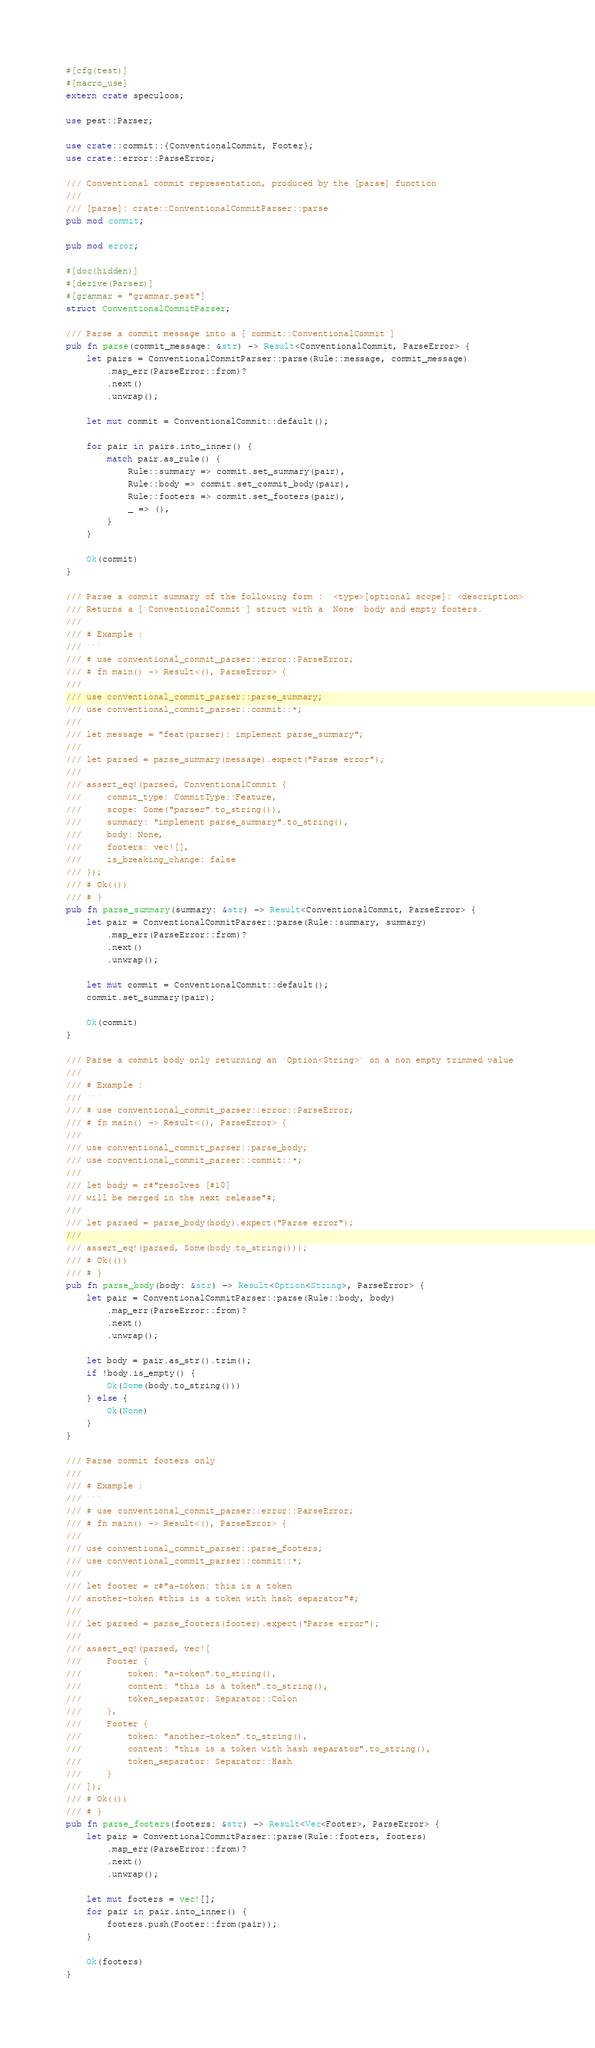Convert code to text. <code><loc_0><loc_0><loc_500><loc_500><_Rust_>#[cfg(test)]
#[macro_use]
extern crate speculoos;

use pest::Parser;

use crate::commit::{ConventionalCommit, Footer};
use crate::error::ParseError;

/// Conventional commit representation, produced by the [parse] function
///
/// [parse]: crate::ConventionalCommitParser::parse
pub mod commit;

pub mod error;

#[doc(hidden)]
#[derive(Parser)]
#[grammar = "grammar.pest"]
struct ConventionalCommitParser;

/// Parse a commit message into a [`commit::ConventionalCommit`]
pub fn parse(commit_message: &str) -> Result<ConventionalCommit, ParseError> {
    let pairs = ConventionalCommitParser::parse(Rule::message, commit_message)
        .map_err(ParseError::from)?
        .next()
        .unwrap();

    let mut commit = ConventionalCommit::default();

    for pair in pairs.into_inner() {
        match pair.as_rule() {
            Rule::summary => commit.set_summary(pair),
            Rule::body => commit.set_commit_body(pair),
            Rule::footers => commit.set_footers(pair),
            _ => (),
        }
    }

    Ok(commit)
}

/// Parse a commit summary of the following form : `<type>[optional scope]: <description>`
/// Returns a [`ConventionalCommit`] struct with a `None` body and empty footers.
///
/// # Example :
/// ```
/// # use conventional_commit_parser::error::ParseError;
/// # fn main() -> Result<(), ParseError> {
///
/// use conventional_commit_parser::parse_summary;
/// use conventional_commit_parser::commit::*;
///
/// let message = "feat(parser): implement parse_summary";
///
/// let parsed = parse_summary(message).expect("Parse error");
///
/// assert_eq!(parsed, ConventionalCommit {
///     commit_type: CommitType::Feature,
///     scope: Some("parser".to_string()),
///     summary: "implement parse_summary".to_string(),
///     body: None,
///     footers: vec![],
///     is_breaking_change: false
/// });
/// # Ok(())
/// # }
pub fn parse_summary(summary: &str) -> Result<ConventionalCommit, ParseError> {
    let pair = ConventionalCommitParser::parse(Rule::summary, summary)
        .map_err(ParseError::from)?
        .next()
        .unwrap();

    let mut commit = ConventionalCommit::default();
    commit.set_summary(pair);

    Ok(commit)
}

/// Parse a commit body only returning an `Option<String>` on a non empty trimmed value
///
/// # Example :
/// ```
/// # use conventional_commit_parser::error::ParseError;
/// # fn main() -> Result<(), ParseError> {
///
/// use conventional_commit_parser::parse_body;
/// use conventional_commit_parser::commit::*;
///
/// let body = r#"resolves [#10]
/// will be merged in the next release"#;
///
/// let parsed = parse_body(body).expect("Parse error");
///
/// assert_eq!(parsed, Some(body.to_string()));
/// # Ok(())
/// # }
pub fn parse_body(body: &str) -> Result<Option<String>, ParseError> {
    let pair = ConventionalCommitParser::parse(Rule::body, body)
        .map_err(ParseError::from)?
        .next()
        .unwrap();

    let body = pair.as_str().trim();
    if !body.is_empty() {
        Ok(Some(body.to_string()))
    } else {
        Ok(None)
    }
}

/// Parse commit footers only
///
/// # Example :
/// ```
/// # use conventional_commit_parser::error::ParseError;
/// # fn main() -> Result<(), ParseError> {
///
/// use conventional_commit_parser::parse_footers;
/// use conventional_commit_parser::commit::*;
///
/// let footer = r#"a-token: this is a token
/// another-token #this is a token with hash separator"#;
///
/// let parsed = parse_footers(footer).expect("Parse error");
///
/// assert_eq!(parsed, vec![
///     Footer {
///         token: "a-token".to_string(),
///         content: "this is a token".to_string(),
///         token_separator: Separator::Colon
///     },
///     Footer {
///         token: "another-token".to_string(),
///         content: "this is a token with hash separator".to_string(),
///         token_separator: Separator::Hash
///     }
/// ]);
/// # Ok(())
/// # }
pub fn parse_footers(footers: &str) -> Result<Vec<Footer>, ParseError> {
    let pair = ConventionalCommitParser::parse(Rule::footers, footers)
        .map_err(ParseError::from)?
        .next()
        .unwrap();

    let mut footers = vec![];
    for pair in pair.into_inner() {
        footers.push(Footer::from(pair));
    }

    Ok(footers)
}
</code> 